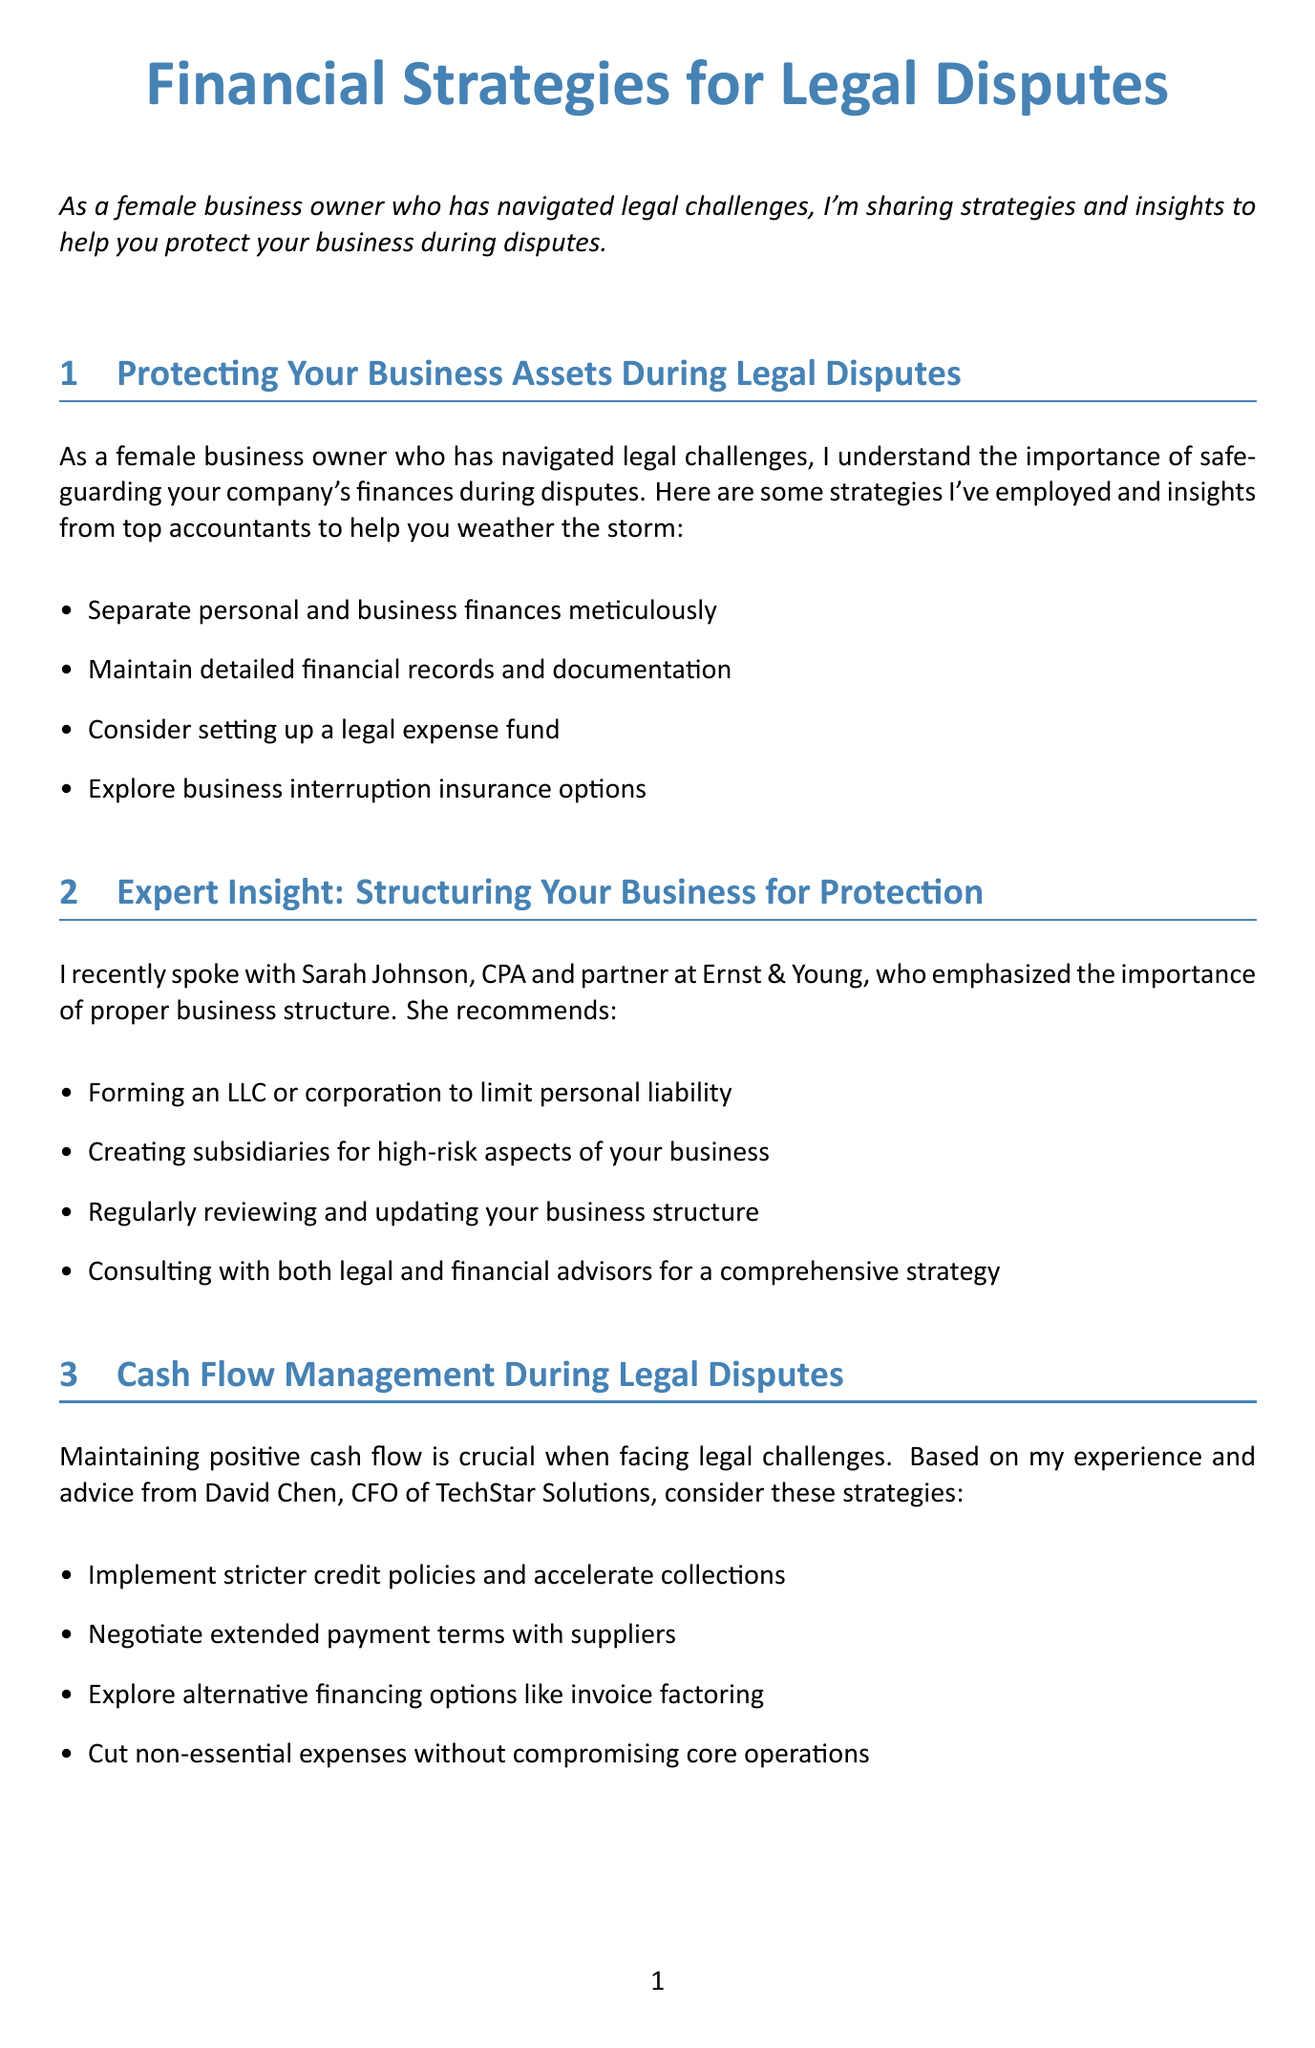What is the main topic of the newsletter? The main topic of the newsletter discusses financial strategies for legal disputes, providing guidance for business owners.
Answer: Financial Strategies for Legal Disputes Who provided insight on structuring your business for protection? Sarah Johnson is cited as a CPA and partner at Ernst & Young, offering recommendations on business structure.
Answer: Sarah Johnson Which type of insurance is mentioned for added protection? The document highlights directors and officers (D&O) insurance as a type of insurance for added protection during legal disputes.
Answer: Directors and officers (D&O) insurance What type of business formation is recommended to limit personal liability? The newsletter suggests forming an LLC or corporation as a way to limit personal liability in business.
Answer: LLC or corporation According to David Chen, what should businesses do to maintain positive cash flow? David Chen recommends implementing stricter credit policies and accelerating collections during legal challenges to maintain positive cash flow.
Answer: Implement stricter credit policies and accelerate collections What is the purpose of a legal expense fund? A legal expense fund is proposed as a strategy to help businesses cover potential legal costs during disputes.
Answer: To cover potential legal costs How many types of bankruptcy are mentioned? The document references three types of bankruptcy which are Chapter 7, Chapter 11, and Chapter 13.
Answer: Three types What does Rachel Goldman advise for debt management before bankruptcy? Rachel Goldman suggests considering debt restructuring options prior to filing for bankruptcy to manage outstanding debts.
Answer: Debt restructuring options Which notable insurance policy is suggested for employment-related issues? Employment practices liability insurance (EPLI) is recommended for protection against employment-related legal issues.
Answer: Employment practices liability insurance (EPLI) 